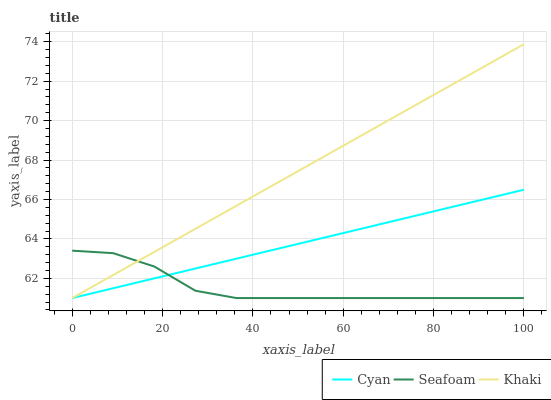Does Seafoam have the minimum area under the curve?
Answer yes or no. Yes. Does Khaki have the maximum area under the curve?
Answer yes or no. Yes. Does Khaki have the minimum area under the curve?
Answer yes or no. No. Does Seafoam have the maximum area under the curve?
Answer yes or no. No. Is Cyan the smoothest?
Answer yes or no. Yes. Is Seafoam the roughest?
Answer yes or no. Yes. Is Khaki the smoothest?
Answer yes or no. No. Is Khaki the roughest?
Answer yes or no. No. Does Cyan have the lowest value?
Answer yes or no. Yes. Does Khaki have the highest value?
Answer yes or no. Yes. Does Seafoam have the highest value?
Answer yes or no. No. Does Khaki intersect Cyan?
Answer yes or no. Yes. Is Khaki less than Cyan?
Answer yes or no. No. Is Khaki greater than Cyan?
Answer yes or no. No. 